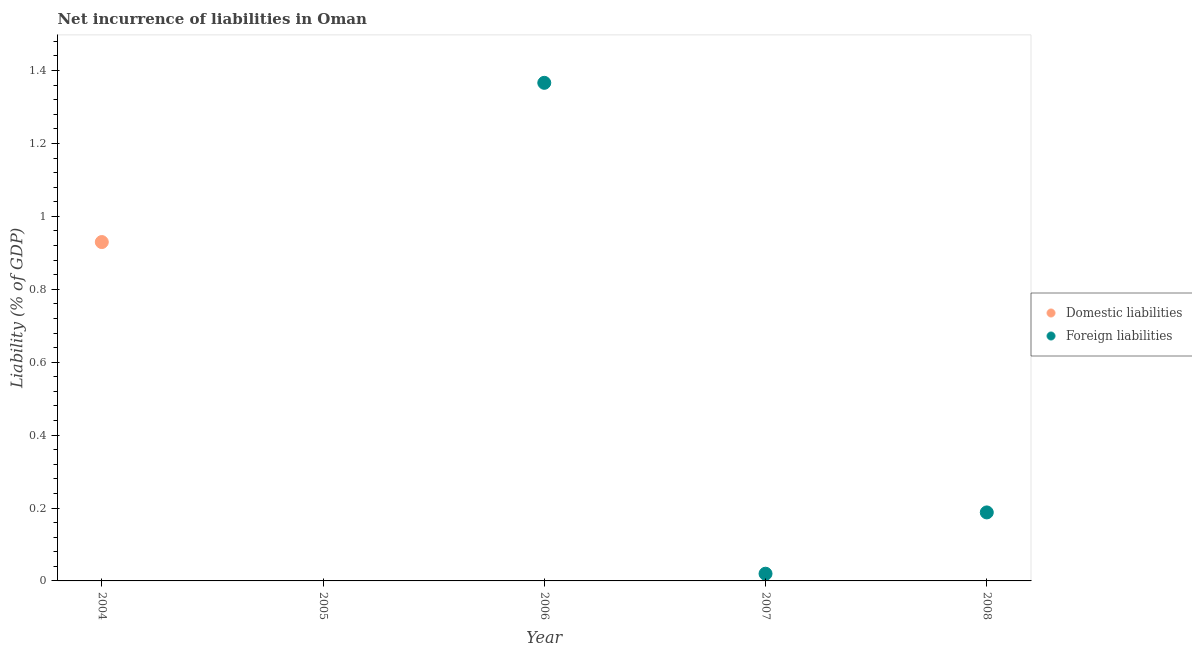How many different coloured dotlines are there?
Your response must be concise. 2. Is the number of dotlines equal to the number of legend labels?
Provide a succinct answer. No. Across all years, what is the maximum incurrence of domestic liabilities?
Your response must be concise. 0.93. What is the total incurrence of domestic liabilities in the graph?
Your response must be concise. 0.93. What is the difference between the incurrence of domestic liabilities in 2004 and the incurrence of foreign liabilities in 2008?
Offer a very short reply. 0.74. What is the average incurrence of foreign liabilities per year?
Offer a terse response. 0.31. In how many years, is the incurrence of domestic liabilities greater than 1.04 %?
Provide a succinct answer. 0. What is the ratio of the incurrence of foreign liabilities in 2006 to that in 2008?
Provide a short and direct response. 7.27. Is the incurrence of foreign liabilities in 2006 less than that in 2008?
Your answer should be compact. No. What is the difference between the highest and the second highest incurrence of foreign liabilities?
Keep it short and to the point. 1.18. What is the difference between the highest and the lowest incurrence of domestic liabilities?
Provide a short and direct response. 0.93. In how many years, is the incurrence of domestic liabilities greater than the average incurrence of domestic liabilities taken over all years?
Provide a succinct answer. 1. Is the sum of the incurrence of foreign liabilities in 2006 and 2007 greater than the maximum incurrence of domestic liabilities across all years?
Your answer should be very brief. Yes. Is the incurrence of domestic liabilities strictly greater than the incurrence of foreign liabilities over the years?
Your response must be concise. No. How many years are there in the graph?
Your response must be concise. 5. What is the difference between two consecutive major ticks on the Y-axis?
Your response must be concise. 0.2. Are the values on the major ticks of Y-axis written in scientific E-notation?
Offer a very short reply. No. How many legend labels are there?
Keep it short and to the point. 2. How are the legend labels stacked?
Offer a very short reply. Vertical. What is the title of the graph?
Your answer should be very brief. Net incurrence of liabilities in Oman. What is the label or title of the X-axis?
Make the answer very short. Year. What is the label or title of the Y-axis?
Make the answer very short. Liability (% of GDP). What is the Liability (% of GDP) of Domestic liabilities in 2004?
Give a very brief answer. 0.93. What is the Liability (% of GDP) of Foreign liabilities in 2004?
Your answer should be very brief. 0. What is the Liability (% of GDP) of Foreign liabilities in 2005?
Make the answer very short. 0. What is the Liability (% of GDP) of Foreign liabilities in 2006?
Make the answer very short. 1.37. What is the Liability (% of GDP) in Foreign liabilities in 2007?
Provide a succinct answer. 0.02. What is the Liability (% of GDP) in Foreign liabilities in 2008?
Make the answer very short. 0.19. Across all years, what is the maximum Liability (% of GDP) of Domestic liabilities?
Ensure brevity in your answer.  0.93. Across all years, what is the maximum Liability (% of GDP) in Foreign liabilities?
Keep it short and to the point. 1.37. Across all years, what is the minimum Liability (% of GDP) of Domestic liabilities?
Your response must be concise. 0. What is the total Liability (% of GDP) in Domestic liabilities in the graph?
Your answer should be compact. 0.93. What is the total Liability (% of GDP) in Foreign liabilities in the graph?
Keep it short and to the point. 1.57. What is the difference between the Liability (% of GDP) of Foreign liabilities in 2006 and that in 2007?
Provide a short and direct response. 1.35. What is the difference between the Liability (% of GDP) in Foreign liabilities in 2006 and that in 2008?
Make the answer very short. 1.18. What is the difference between the Liability (% of GDP) in Foreign liabilities in 2007 and that in 2008?
Make the answer very short. -0.17. What is the difference between the Liability (% of GDP) in Domestic liabilities in 2004 and the Liability (% of GDP) in Foreign liabilities in 2006?
Your answer should be very brief. -0.44. What is the difference between the Liability (% of GDP) of Domestic liabilities in 2004 and the Liability (% of GDP) of Foreign liabilities in 2007?
Provide a succinct answer. 0.91. What is the difference between the Liability (% of GDP) of Domestic liabilities in 2004 and the Liability (% of GDP) of Foreign liabilities in 2008?
Give a very brief answer. 0.74. What is the average Liability (% of GDP) of Domestic liabilities per year?
Offer a very short reply. 0.19. What is the average Liability (% of GDP) of Foreign liabilities per year?
Offer a terse response. 0.31. What is the ratio of the Liability (% of GDP) in Foreign liabilities in 2006 to that in 2007?
Provide a short and direct response. 69.09. What is the ratio of the Liability (% of GDP) of Foreign liabilities in 2006 to that in 2008?
Provide a short and direct response. 7.27. What is the ratio of the Liability (% of GDP) in Foreign liabilities in 2007 to that in 2008?
Provide a succinct answer. 0.11. What is the difference between the highest and the second highest Liability (% of GDP) of Foreign liabilities?
Provide a short and direct response. 1.18. What is the difference between the highest and the lowest Liability (% of GDP) in Domestic liabilities?
Your response must be concise. 0.93. What is the difference between the highest and the lowest Liability (% of GDP) in Foreign liabilities?
Make the answer very short. 1.37. 